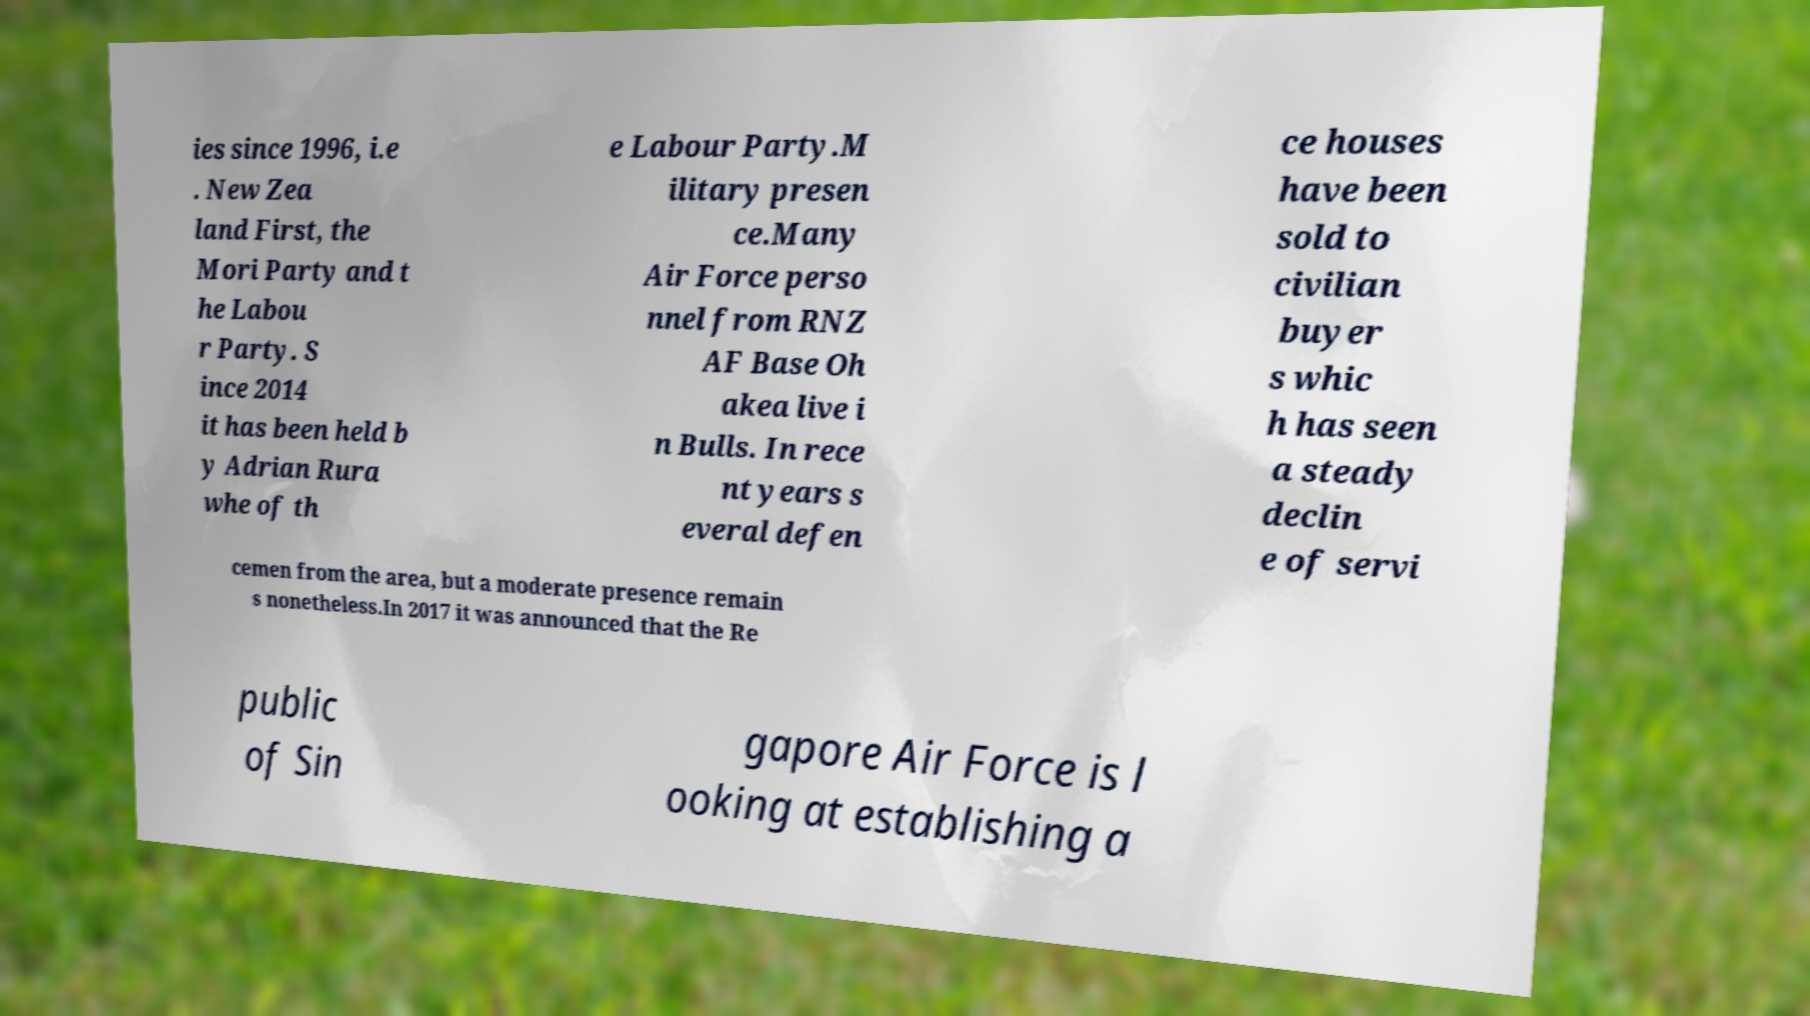Can you accurately transcribe the text from the provided image for me? ies since 1996, i.e . New Zea land First, the Mori Party and t he Labou r Party. S ince 2014 it has been held b y Adrian Rura whe of th e Labour Party.M ilitary presen ce.Many Air Force perso nnel from RNZ AF Base Oh akea live i n Bulls. In rece nt years s everal defen ce houses have been sold to civilian buyer s whic h has seen a steady declin e of servi cemen from the area, but a moderate presence remain s nonetheless.In 2017 it was announced that the Re public of Sin gapore Air Force is l ooking at establishing a 